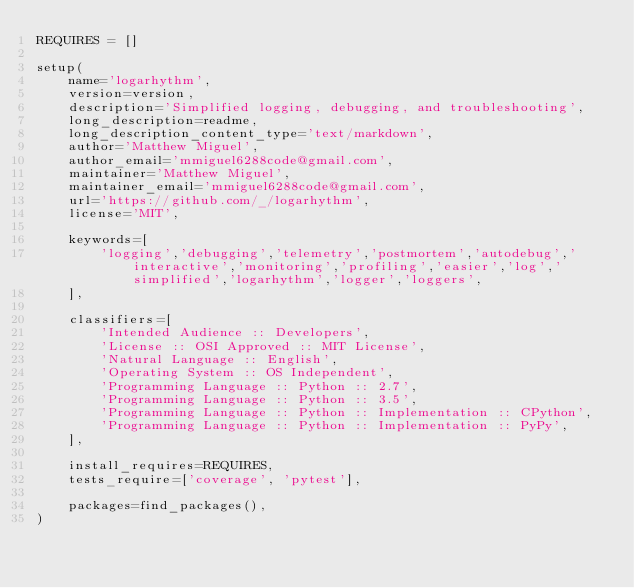Convert code to text. <code><loc_0><loc_0><loc_500><loc_500><_Python_>REQUIRES = []

setup(
    name='logarhythm',
    version=version,
    description='Simplified logging, debugging, and troubleshooting',
    long_description=readme,
    long_description_content_type='text/markdown',
    author='Matthew Miguel',
    author_email='mmiguel6288code@gmail.com',
    maintainer='Matthew Miguel',
    maintainer_email='mmiguel6288code@gmail.com',
    url='https://github.com/_/logarhythm',
    license='MIT',

    keywords=[
        'logging','debugging','telemetry','postmortem','autodebug','interactive','monitoring','profiling','easier','log','simplified','logarhythm','logger','loggers',
    ],

    classifiers=[
        'Intended Audience :: Developers',
        'License :: OSI Approved :: MIT License',
        'Natural Language :: English',
        'Operating System :: OS Independent',
        'Programming Language :: Python :: 2.7',
        'Programming Language :: Python :: 3.5',
        'Programming Language :: Python :: Implementation :: CPython',
        'Programming Language :: Python :: Implementation :: PyPy',
    ],

    install_requires=REQUIRES,
    tests_require=['coverage', 'pytest'],

    packages=find_packages(),
)
</code> 